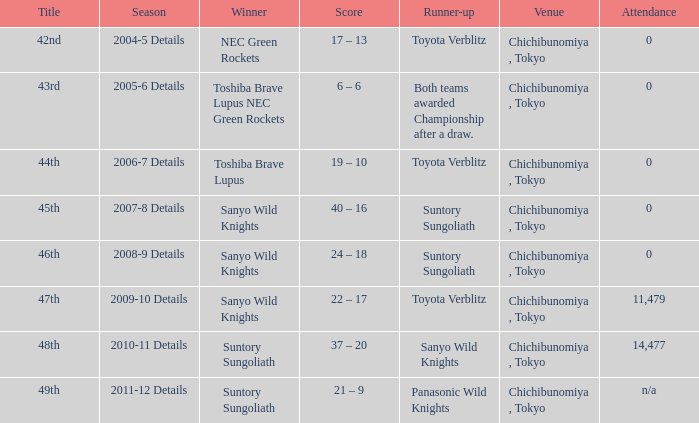What is the score when the victor was sanyo wild knights, and a second-place finisher of suntory sungoliath? 40 – 16, 24 – 18. 